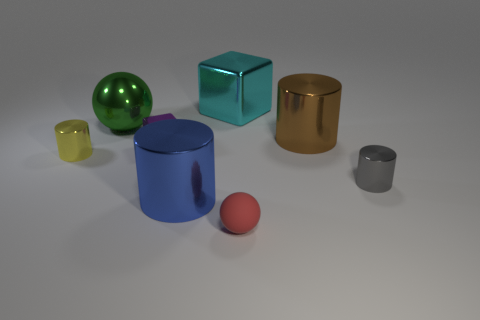Subtract all big brown cylinders. How many cylinders are left? 3 Add 2 purple shiny blocks. How many objects exist? 10 Subtract all blue cylinders. How many cylinders are left? 3 Subtract 2 cubes. How many cubes are left? 0 Subtract all gray cylinders. Subtract all blue blocks. How many cylinders are left? 3 Subtract all red cubes. How many yellow cylinders are left? 1 Subtract all red metallic cylinders. Subtract all tiny purple cubes. How many objects are left? 7 Add 5 rubber balls. How many rubber balls are left? 6 Add 7 gray cylinders. How many gray cylinders exist? 8 Subtract 0 gray blocks. How many objects are left? 8 